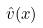<formula> <loc_0><loc_0><loc_500><loc_500>\hat { v } ( x )</formula> 